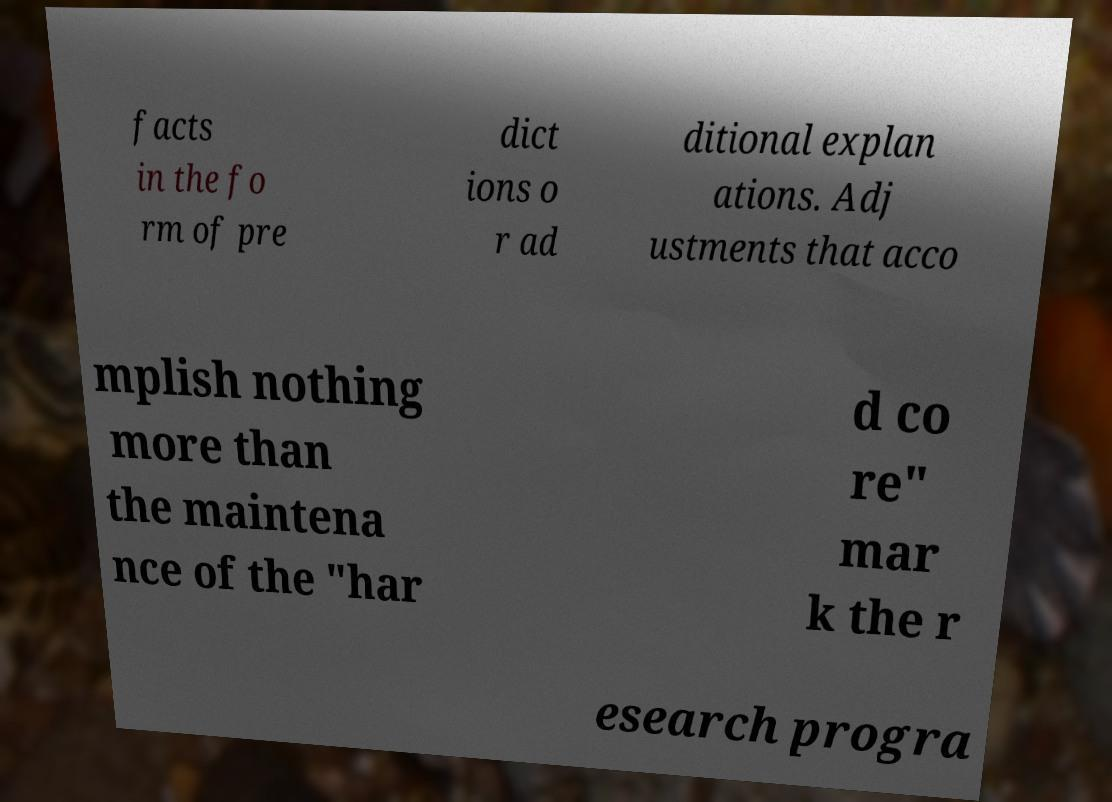For documentation purposes, I need the text within this image transcribed. Could you provide that? facts in the fo rm of pre dict ions o r ad ditional explan ations. Adj ustments that acco mplish nothing more than the maintena nce of the "har d co re" mar k the r esearch progra 